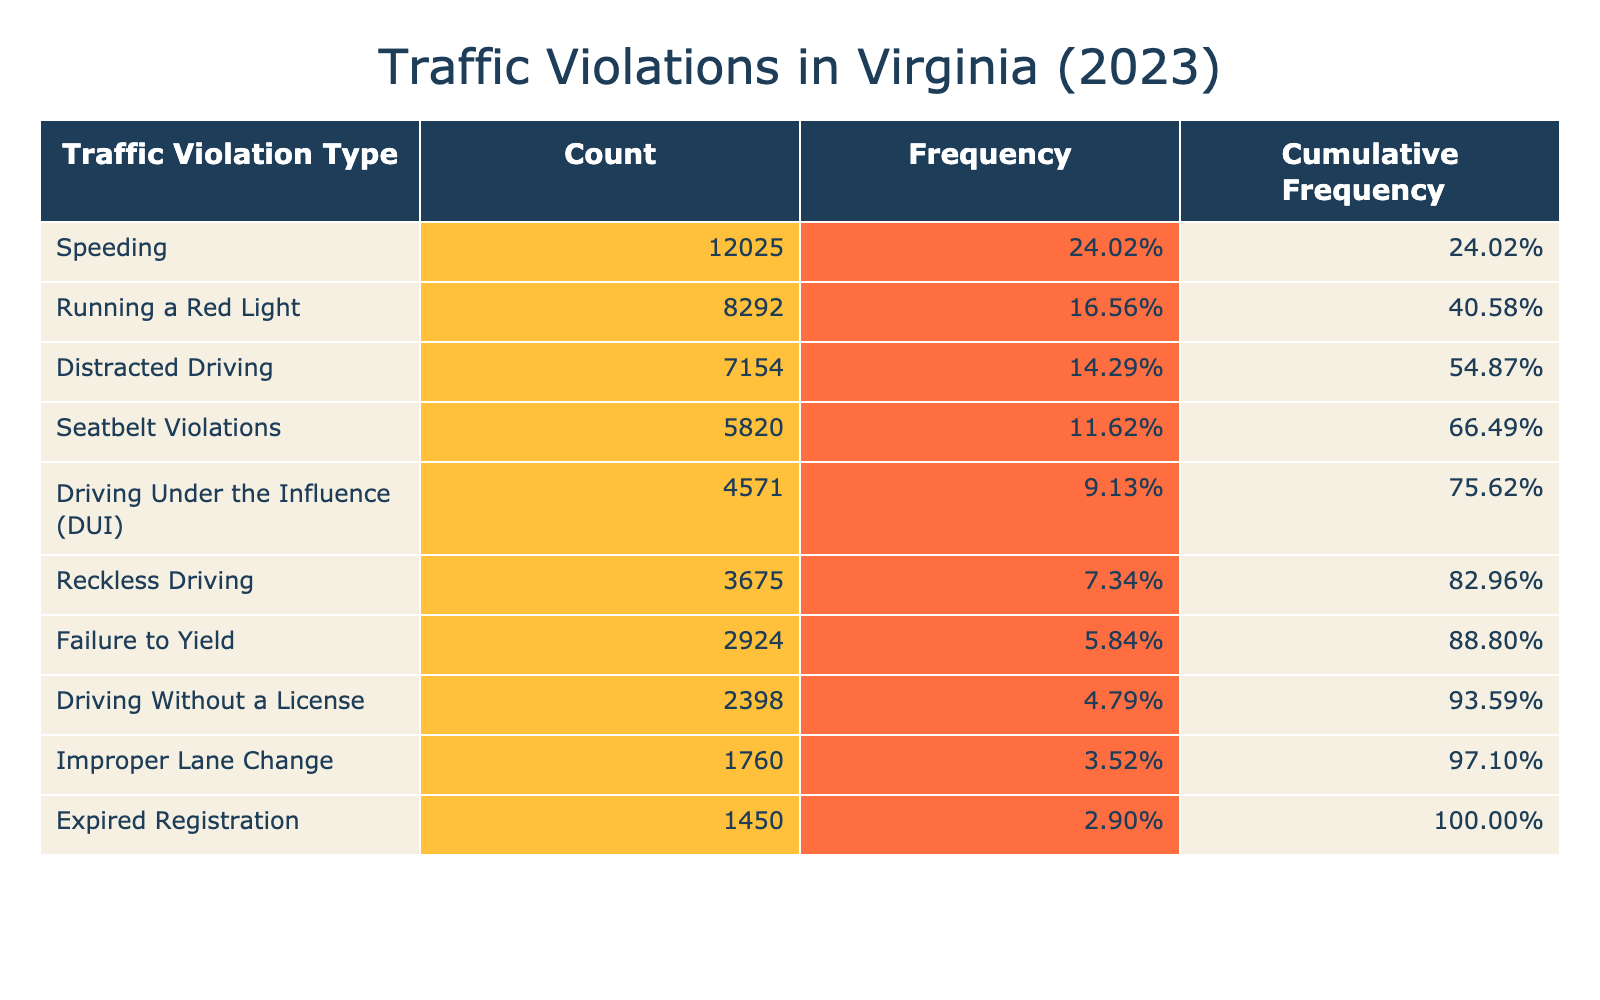What is the most common type of traffic violation in Virginia in 2023? The violation with the highest count is "Speeding" with 12025 occurrences, making it the most common type of traffic violation in the table.
Answer: Speeding How many traffic violations related to "Driving Without a License" were recorded? The table shows that there were 2398 instances of "Driving Without a License."
Answer: 2398 What is the cumulative frequency of "Reckless Driving"? The cumulative frequency includes all counts up to and including "Reckless Driving." To find it, add the counts of all violations before "Reckless Driving" (12025 + 4571 + 8292 + 2398 + 3675), which equals 26461. The cumulative frequency for "Reckless Driving" itself is therefore 26461 and 3675 is added to it, summing to 30136. The cumulative frequency for "Reckless Driving" is 30136.
Answer: 30136 What percentage of total traffic violations does "Distracted Driving" represent? First, calculate the total number of violations by summing all counts: 12025 + 4571 + 8292 + 2398 + 3675 + 5820 + 7154 + 2924 + 1760 + 1450 = 41109. To find the percentage, divide the count for "Distracted Driving" (7154) by the total (41109) and multiply by 100: (7154 / 41109) * 100 = 17.39%.
Answer: 17.39% Is "Expired Registration" among the top three traffic violations by count? The top three violations based on count are "Speeding," "Running a Red Light," and "Distracted Driving." "Expired Registration" (1450) is lower than these three, so it is not in the top three.
Answer: No How many more violations were there for "Running a Red Light" compared to "Driving Without a License"? "Running a Red Light" has 8292 violations, while "Driving Without a License" has 2398. To find the difference, subtract the latter from the former: 8292 - 2398 = 5894.
Answer: 5894 What is the total number of violations for the types that involve driving behaviors (i.e., DUI, Reckless Driving, Distracted Driving)? Count for DUI is 4571, Reckless Driving is 3675, and Distracted Driving is 7154. Adding these counts together: 4571 + 3675 + 7154 = 15400.
Answer: 15400 What traffic violation type has the lowest count? The lowest count is for "Expired Registration," which has only 1450 violations, making it the least common type of traffic violation in the table.
Answer: Expired Registration 